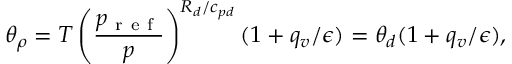<formula> <loc_0><loc_0><loc_500><loc_500>\theta _ { \rho } = T \left ( \frac { p _ { r e f } } { p } \right ) ^ { R _ { d } / c _ { p d } } ( 1 + q _ { v } / \epsilon ) = \theta _ { d } ( 1 + q _ { v } / \epsilon ) ,</formula> 